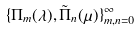<formula> <loc_0><loc_0><loc_500><loc_500>\{ \Pi _ { m } ( \lambda ) , { \tilde { \Pi } } _ { n } ( \mu ) \} _ { m , n = 0 } ^ { \infty }</formula> 